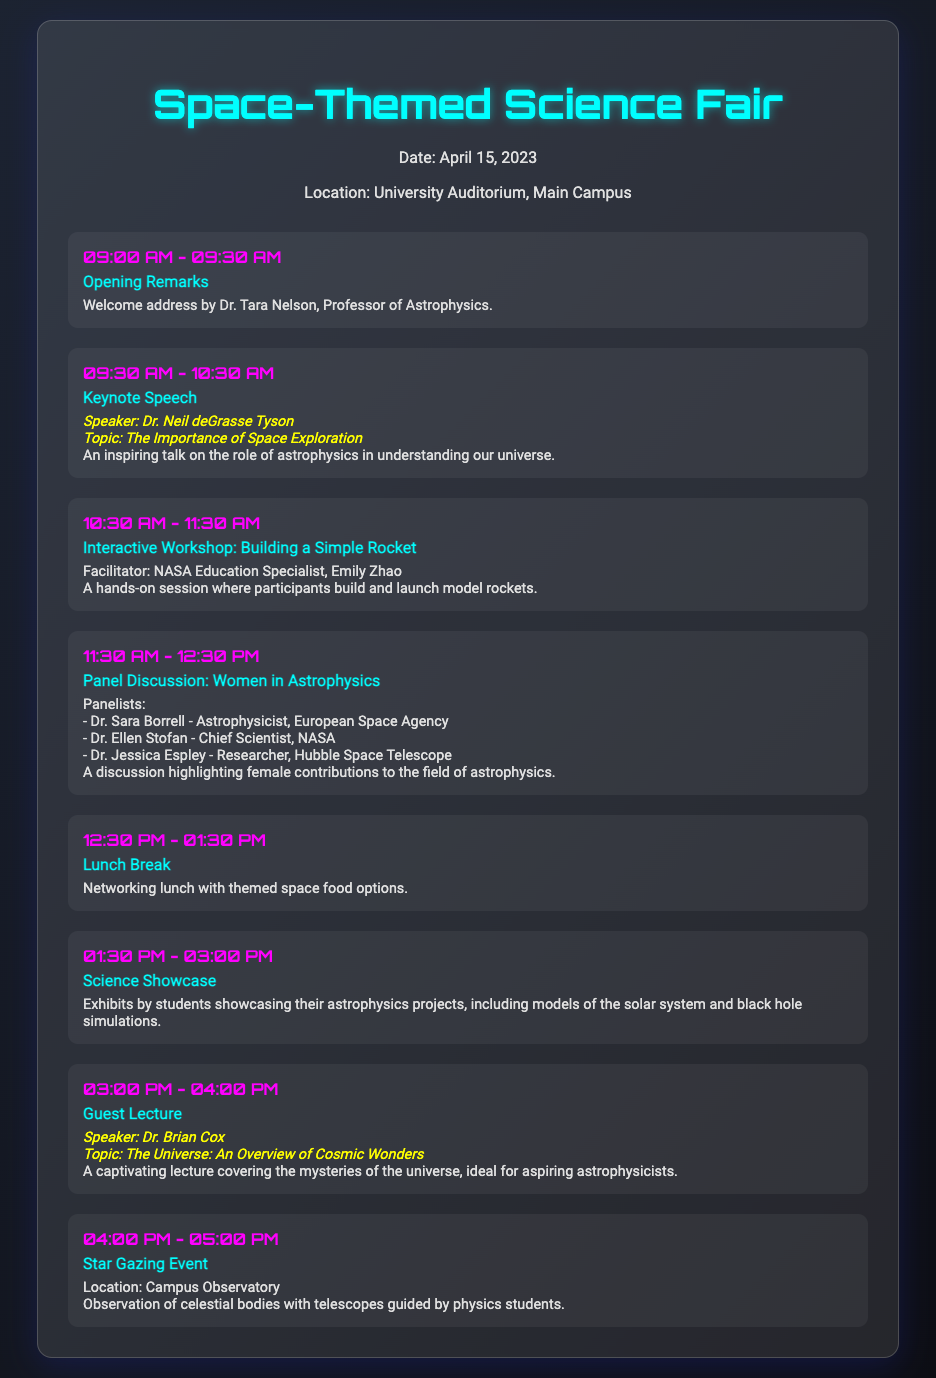what date is the event? The date of the event is explicitly stated in the document.
Answer: April 15, 2023 who is the keynote speaker? The document provides information about the keynote speaker including their name and details about their speech.
Answer: Dr. Neil deGrasse Tyson what activity occurs during the 12:30 PM - 01:30 PM slot? The schedule lists each activity along with its corresponding time, including this specific time slot.
Answer: Lunch Break how many panelists are featured in the discussion on women in astrophysics? The document lists each panelist and their titles, allowing us to count the total number.
Answer: Three which activity includes building and launching model rockets? By examining the details of each scheduled activity, we can identify this specific hands-on session.
Answer: Interactive Workshop: Building a Simple Rocket what is the location of the star gazing event? The details of each scheduled event describe its associated location very clearly.
Answer: Campus Observatory what is the main topic of Dr. Brian Cox's guest lecture? The document specifies the topics of the guest lectures, revealing the main subject of this lecture.
Answer: The Universe: An Overview of Cosmic Wonders who welcomes the attendees at the opening remarks? The document names the person giving the opening remarks along with their title.
Answer: Dr. Tara Nelson 